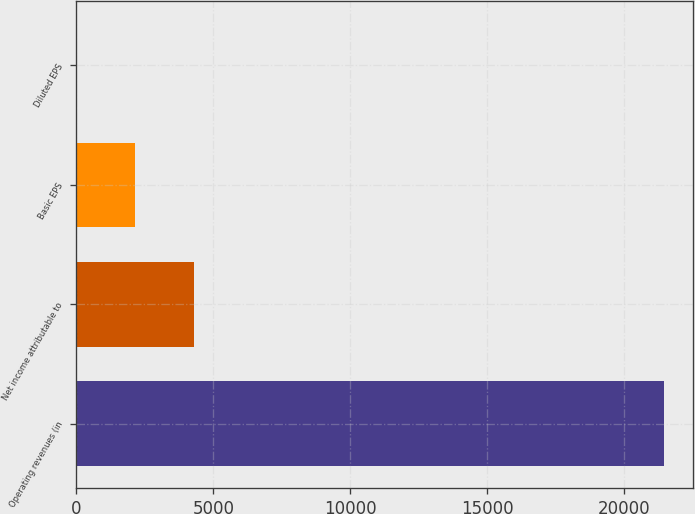Convert chart. <chart><loc_0><loc_0><loc_500><loc_500><bar_chart><fcel>Operating revenues (in<fcel>Net income attributable to<fcel>Basic EPS<fcel>Diluted EPS<nl><fcel>21430<fcel>4288.28<fcel>2145.56<fcel>2.84<nl></chart> 